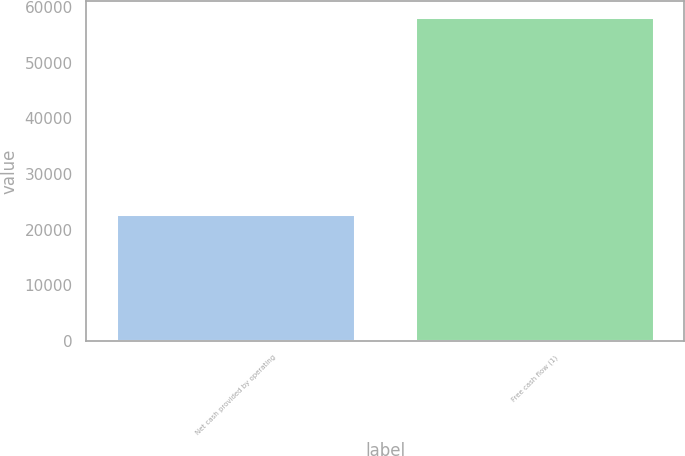Convert chart. <chart><loc_0><loc_0><loc_500><loc_500><bar_chart><fcel>Net cash provided by operating<fcel>Free cash flow (1)<nl><fcel>22765<fcel>58151<nl></chart> 